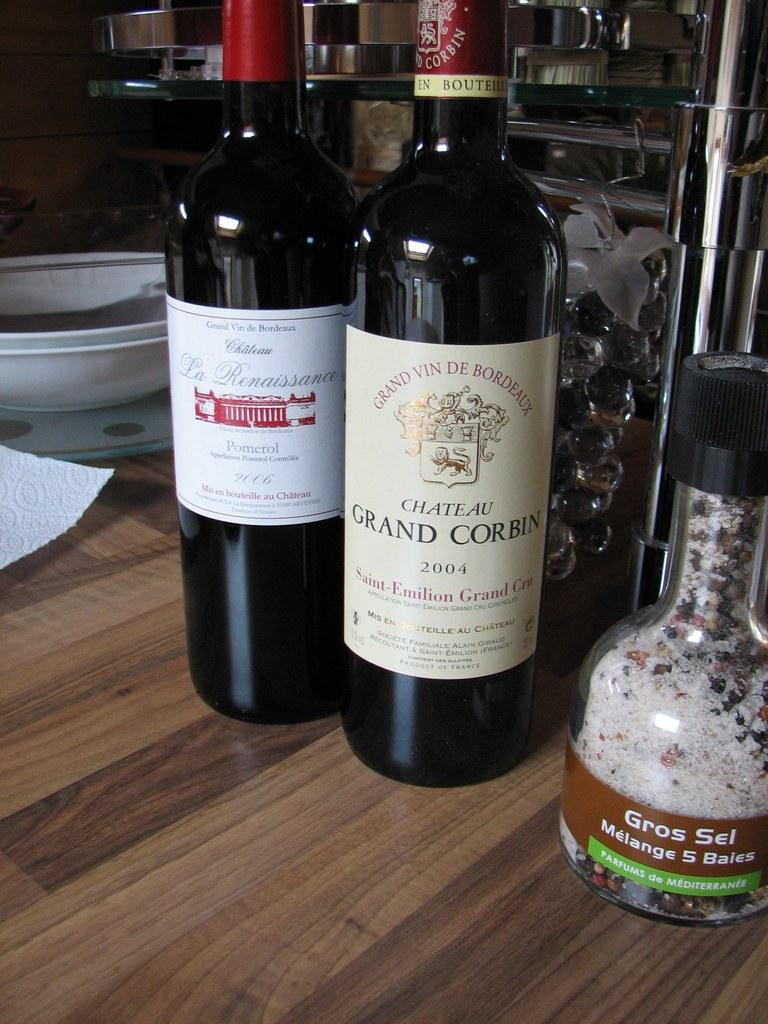<image>
Present a compact description of the photo's key features. Two wine bottles are on a table next to Gros Sel Melange 5 Baies. 